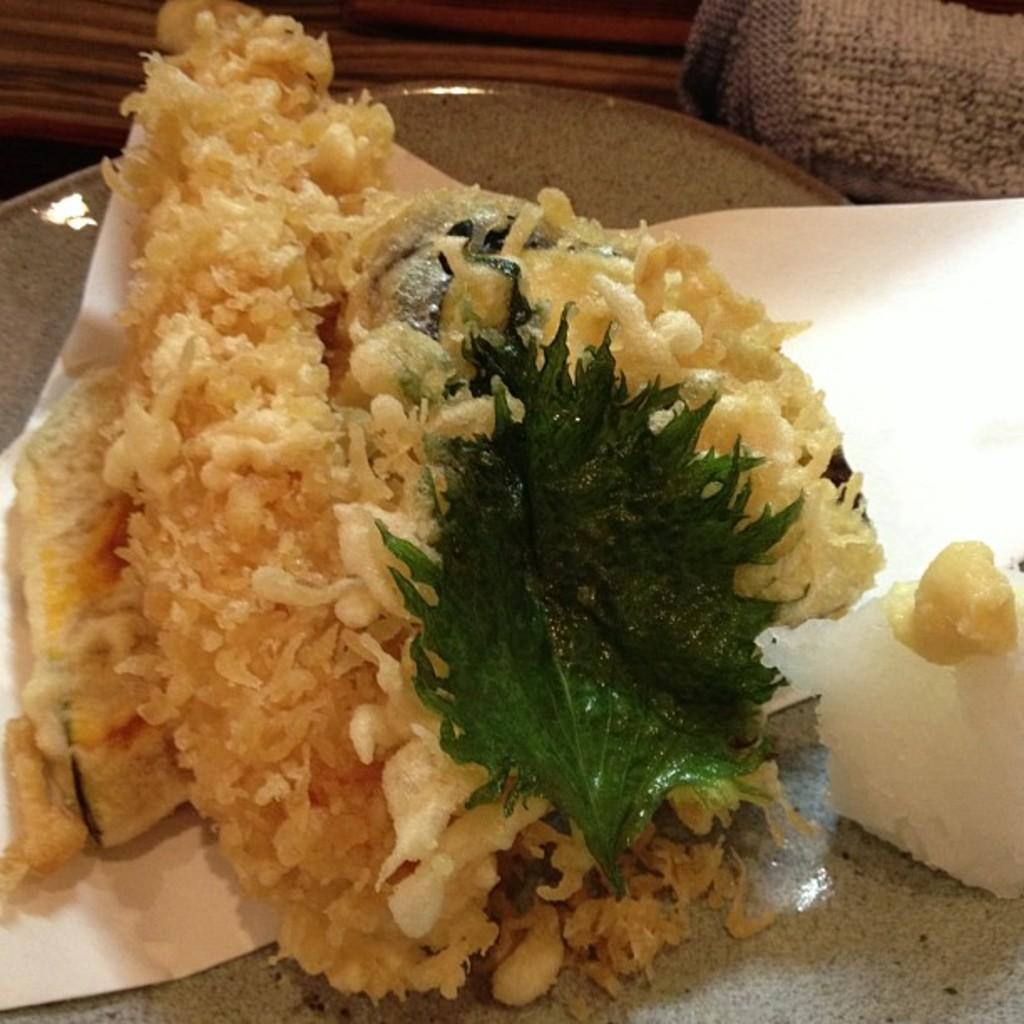Please provide a concise description of this image. In this picture we can see food items, paper, leaf and some objects. 